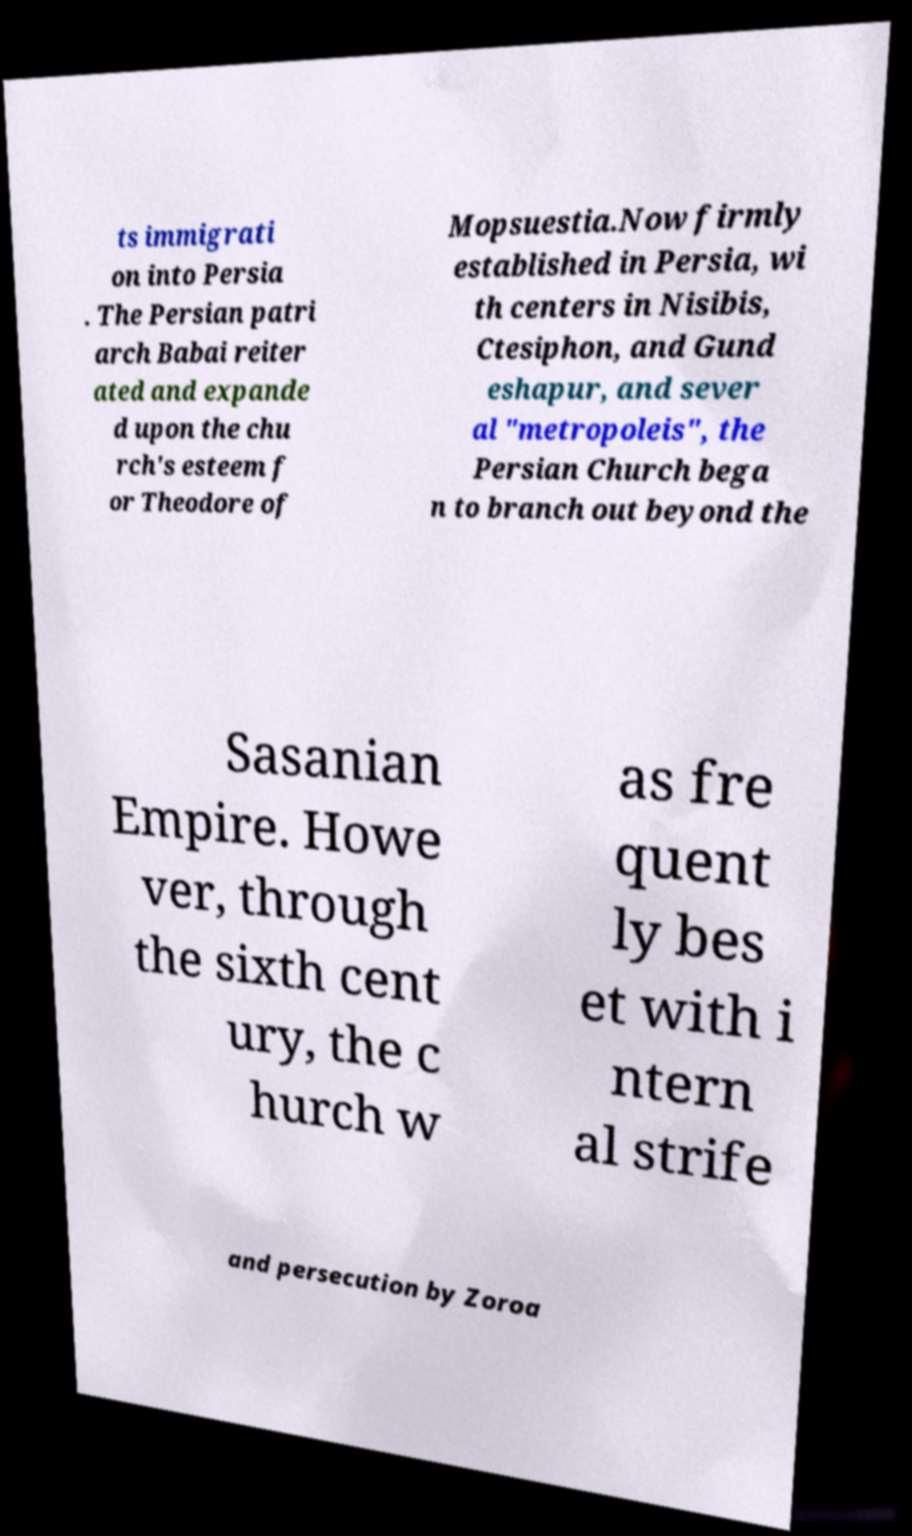What messages or text are displayed in this image? I need them in a readable, typed format. ts immigrati on into Persia . The Persian patri arch Babai reiter ated and expande d upon the chu rch's esteem f or Theodore of Mopsuestia.Now firmly established in Persia, wi th centers in Nisibis, Ctesiphon, and Gund eshapur, and sever al "metropoleis", the Persian Church bega n to branch out beyond the Sasanian Empire. Howe ver, through the sixth cent ury, the c hurch w as fre quent ly bes et with i ntern al strife and persecution by Zoroa 